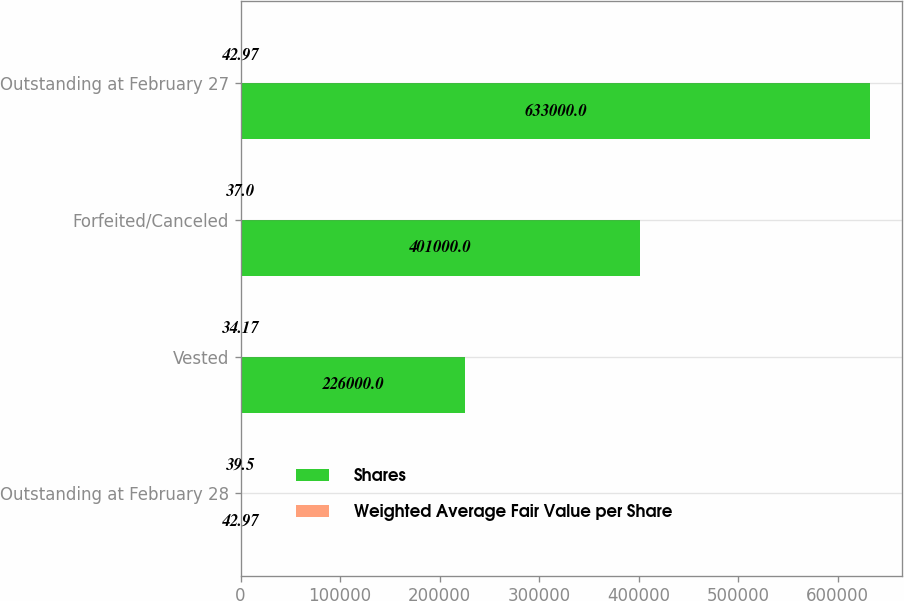Convert chart. <chart><loc_0><loc_0><loc_500><loc_500><stacked_bar_chart><ecel><fcel>Outstanding at February 28<fcel>Vested<fcel>Forfeited/Canceled<fcel>Outstanding at February 27<nl><fcel>Shares<fcel>42.97<fcel>226000<fcel>401000<fcel>633000<nl><fcel>Weighted Average Fair Value per Share<fcel>39.5<fcel>34.17<fcel>37<fcel>42.97<nl></chart> 